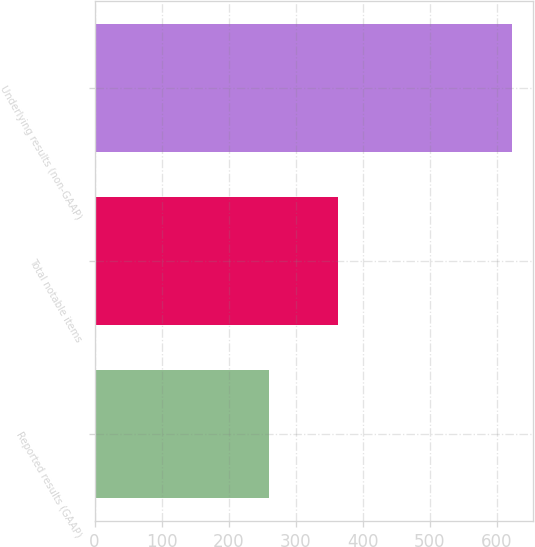Convert chart to OTSL. <chart><loc_0><loc_0><loc_500><loc_500><bar_chart><fcel>Reported results (GAAP)<fcel>Total notable items<fcel>Underlying results (non-GAAP)<nl><fcel>260<fcel>363<fcel>623<nl></chart> 